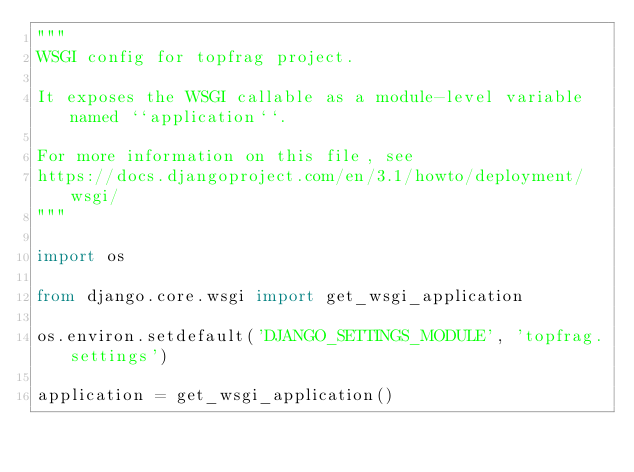Convert code to text. <code><loc_0><loc_0><loc_500><loc_500><_Python_>"""
WSGI config for topfrag project.

It exposes the WSGI callable as a module-level variable named ``application``.

For more information on this file, see
https://docs.djangoproject.com/en/3.1/howto/deployment/wsgi/
"""

import os

from django.core.wsgi import get_wsgi_application

os.environ.setdefault('DJANGO_SETTINGS_MODULE', 'topfrag.settings')

application = get_wsgi_application()
</code> 